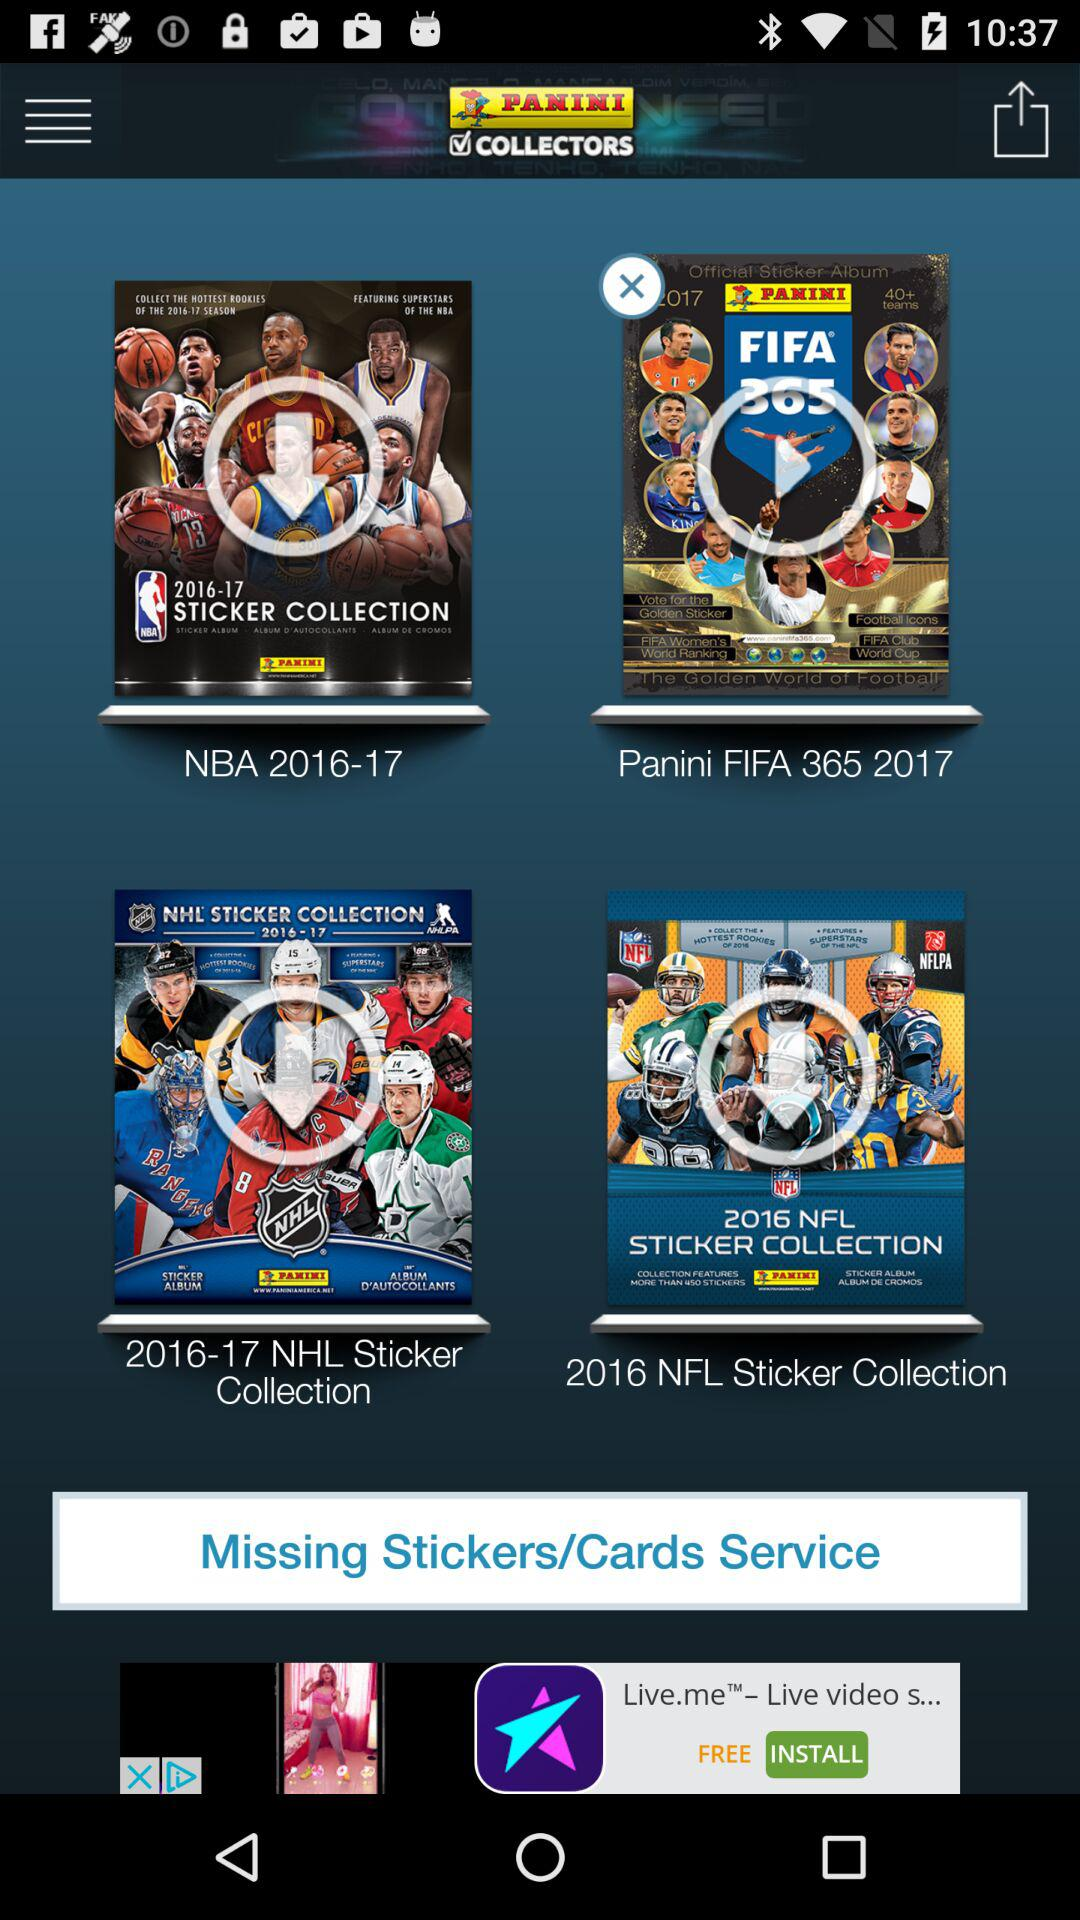What is the year of the "2016 NFL Sticker Collection"? The year is 2016. 